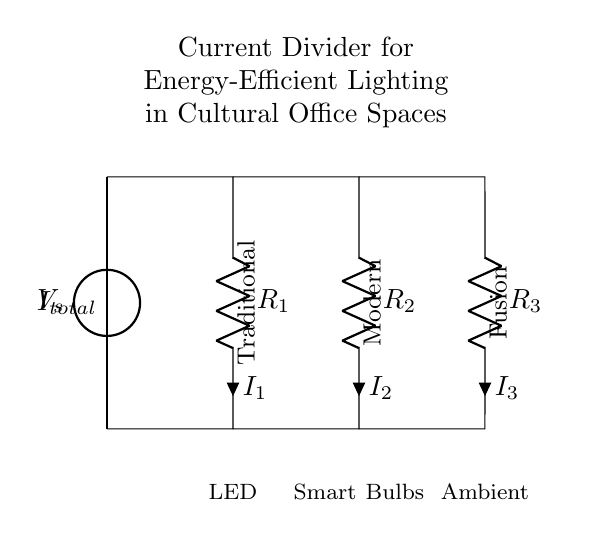what is the total current represented in this circuit? The total current, represented as I total, is the sum of the currents through all parallel branches. It indicates how much current is supplied by the voltage source to the entire circuit.
Answer: I total what are the three types of lighting systems used in this circuit? The circuit diagram labels three lighting systems: LED, Smart Bulbs, and Ambient. Each type is associated with a specific resistor and represents different lighting technologies.
Answer: LED, Smart Bulbs, Ambient how many parallel branches are in this current divider circuit? The circuit features three parallel branches, each connected to a different type of lighting system. This allows for the division of current among them, based on their individual resistances.
Answer: 3 which branch has the traditional cultural theme? The circuit diagram labels the branch connected to resistor R 2 as traditional. This branch's theme reflects a particular cultural style in the office space.
Answer: Traditional what is the relationship between individual currents and total current in a current divider? In a current divider, the total current is split among the parallel branches inversely proportional to their resistances. The lower the resistance, the higher the current flowing through that branch, maintaining constant voltage across all branches.
Answer: Inversely proportional which lighting system would likely use the most current? The lighting system with the lowest resistance will draw the most current due to the principles of current division. By looking at the resistive values, we can identify the one with the lowest resistance.
Answer: Smart Bulbs (typically) what cultural theme does the branch labeled "Fusion" represent? The "Fusion" label indicates a lighting system that creatively combines elements from different cultural themes, showcasing a modern and innovative approach to office space design.
Answer: Fusion 